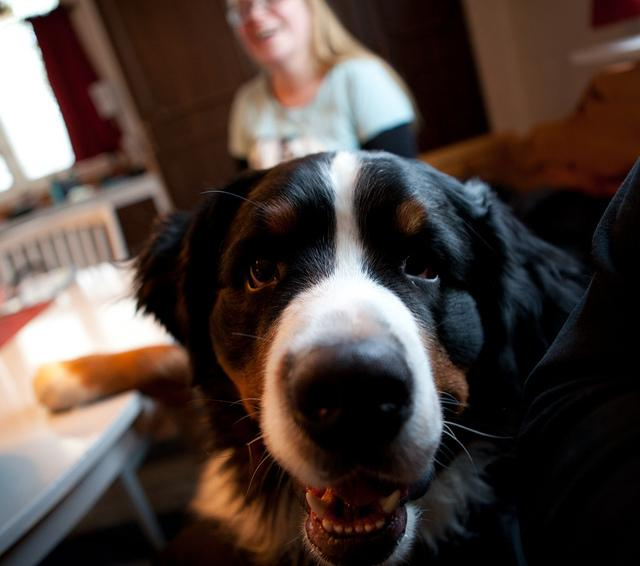What are they looking at? camera 